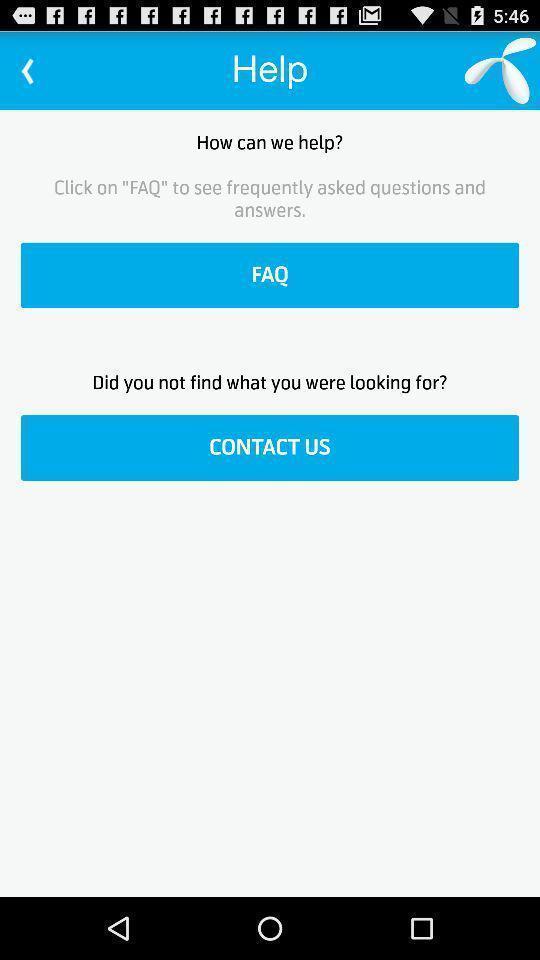Provide a description of this screenshot. Screen shows help options. 